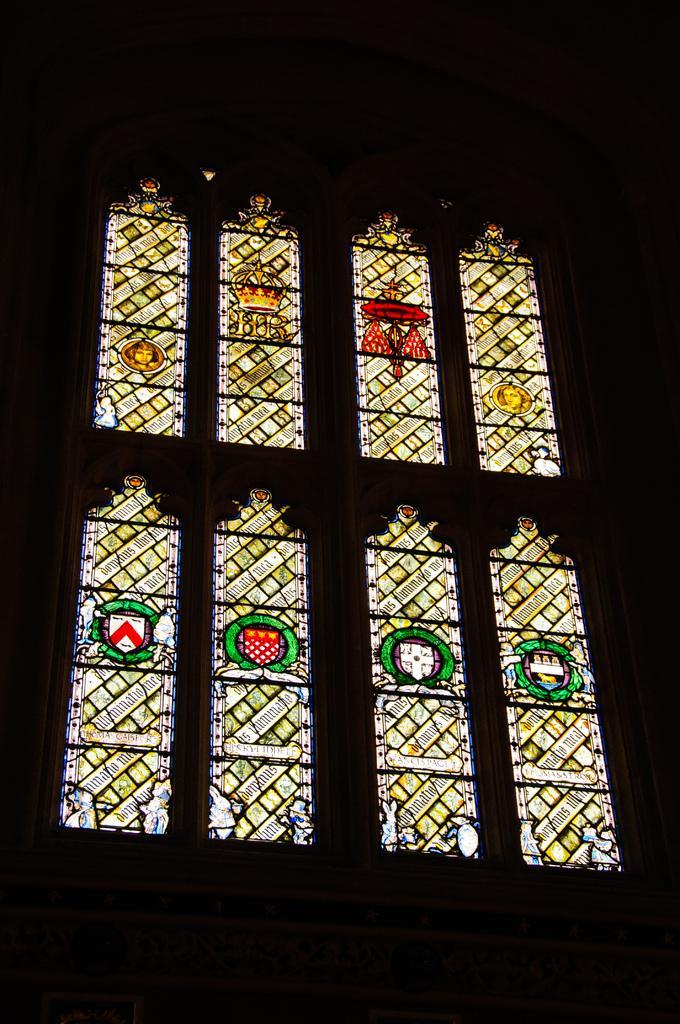Can you describe this image briefly? In this image there are windows to a wall. 